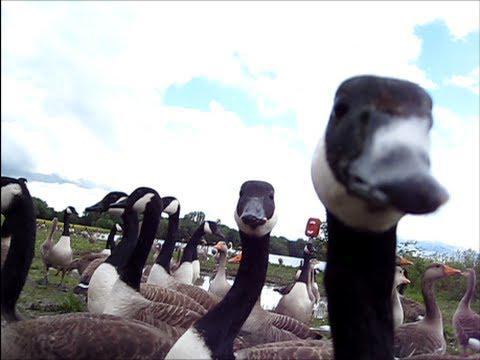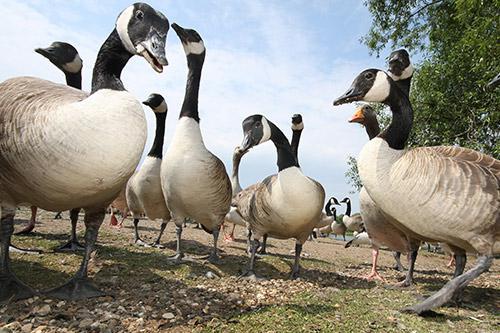The first image is the image on the left, the second image is the image on the right. Examine the images to the left and right. Is the description "In one image, two birds have wings outstretched with at least one of them in mid air." accurate? Answer yes or no. No. The first image is the image on the left, the second image is the image on the right. Evaluate the accuracy of this statement regarding the images: "There is one eagle". Is it true? Answer yes or no. No. 